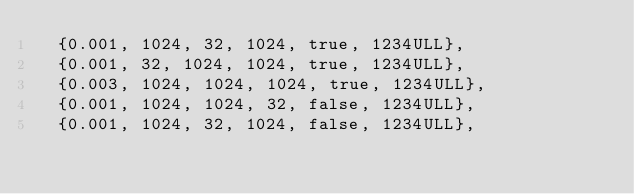Convert code to text. <code><loc_0><loc_0><loc_500><loc_500><_Cuda_>  {0.001, 1024, 32, 1024, true, 1234ULL},
  {0.001, 32, 1024, 1024, true, 1234ULL},
  {0.003, 1024, 1024, 1024, true, 1234ULL},
  {0.001, 1024, 1024, 32, false, 1234ULL},
  {0.001, 1024, 32, 1024, false, 1234ULL},</code> 